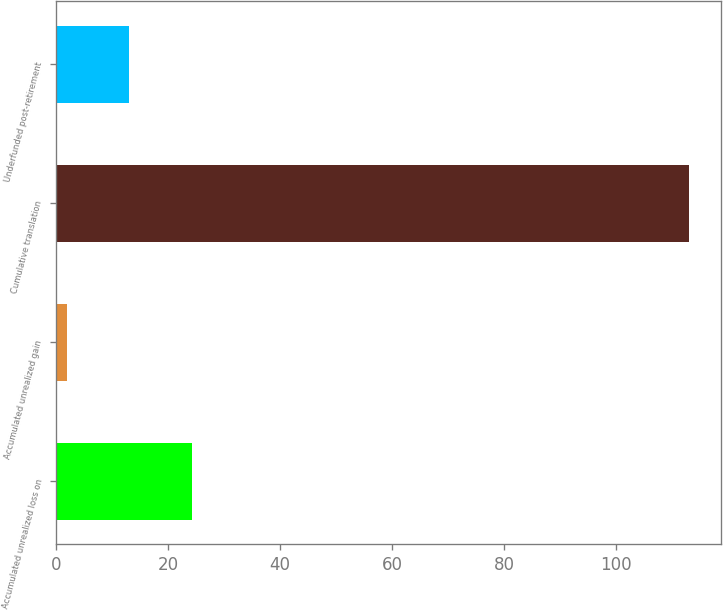Convert chart to OTSL. <chart><loc_0><loc_0><loc_500><loc_500><bar_chart><fcel>Accumulated unrealized loss on<fcel>Accumulated unrealized gain<fcel>Cumulative translation<fcel>Underfunded post-retirement<nl><fcel>24.2<fcel>2<fcel>113<fcel>13.1<nl></chart> 